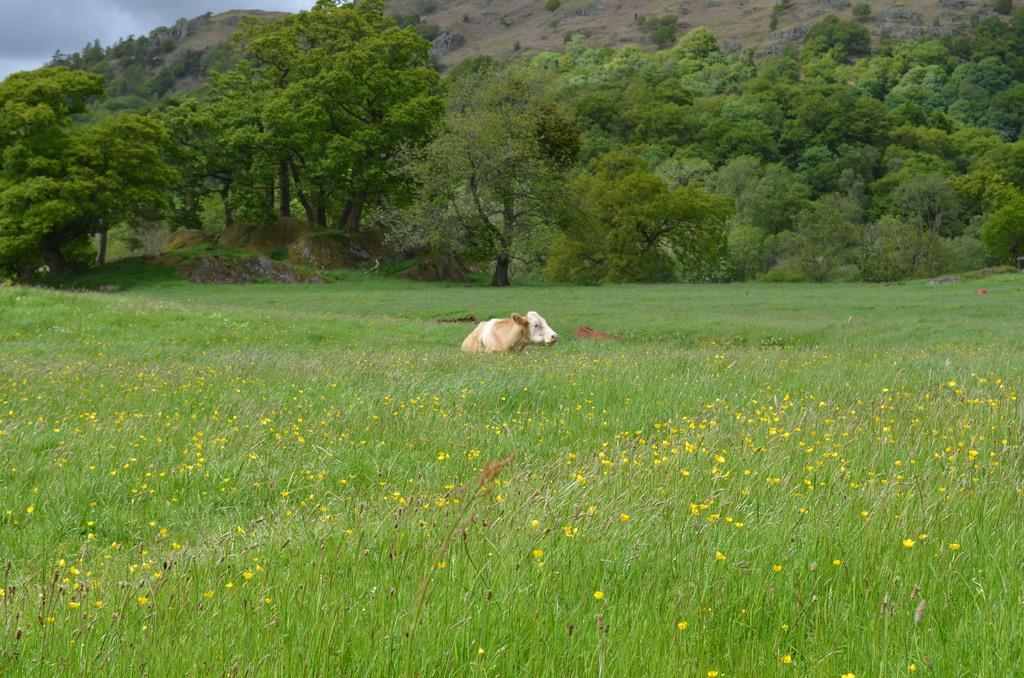What type of outdoor space is shown in the image? There is a garden in the image. What animal can be seen in the grass? There is a calf in the grass. What can be seen in the distance in the background of the image? There are trees and a mountain in the background of the image. What type of pleasure does the writer experience while observing the garden in the image? There is no writer present in the image, and therefore no information about their experience or pleasure can be determined. 